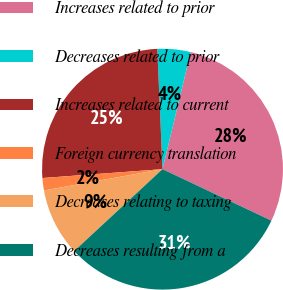Convert chart. <chart><loc_0><loc_0><loc_500><loc_500><pie_chart><fcel>Increases related to prior<fcel>Decreases related to prior<fcel>Increases related to current<fcel>Foreign currency translation<fcel>Decreases relating to taxing<fcel>Decreases resulting from a<nl><fcel>28.27%<fcel>4.45%<fcel>25.48%<fcel>1.66%<fcel>9.07%<fcel>31.06%<nl></chart> 